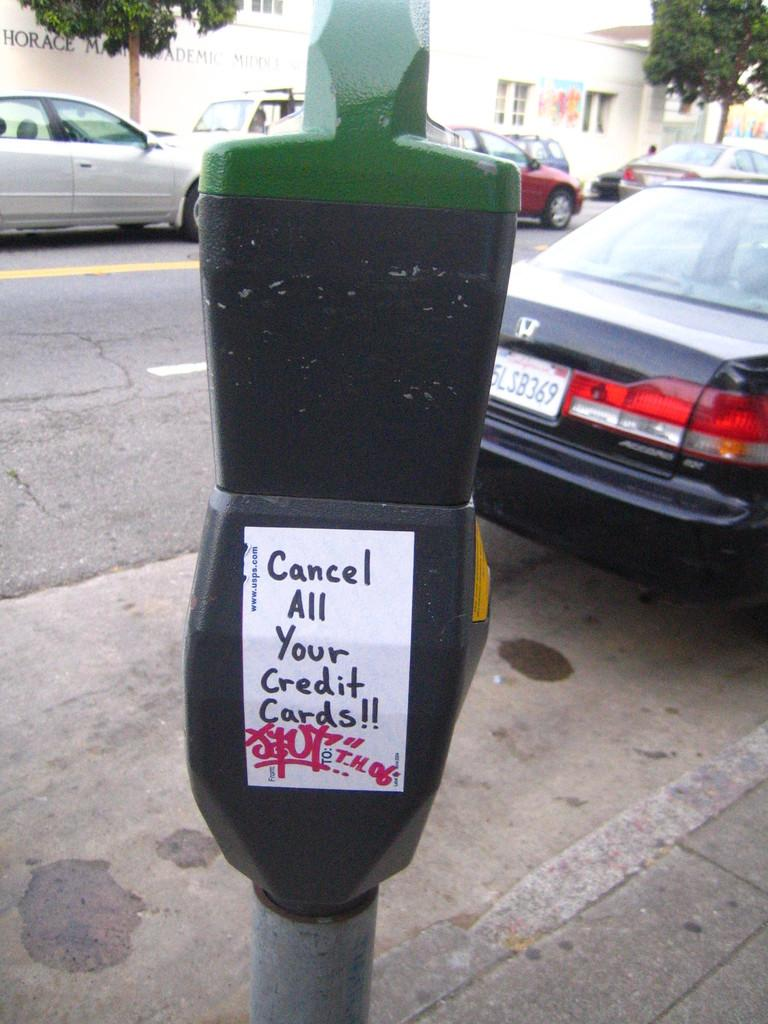<image>
Create a compact narrative representing the image presented. A parking meter with a paper with the text cancel all your credit cards written on it. 